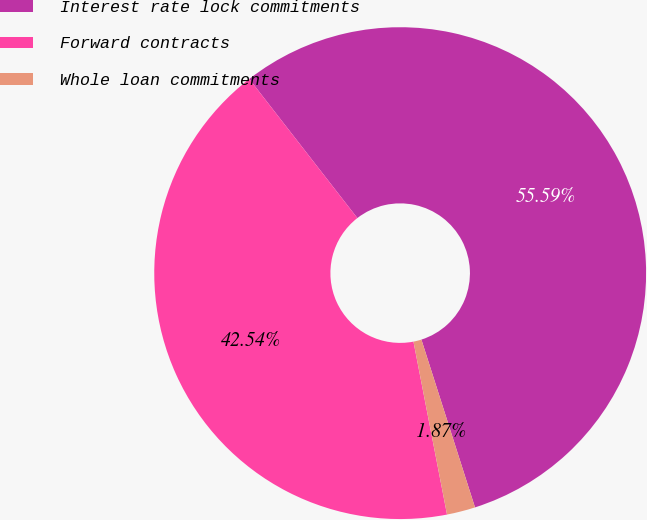Convert chart to OTSL. <chart><loc_0><loc_0><loc_500><loc_500><pie_chart><fcel>Interest rate lock commitments<fcel>Forward contracts<fcel>Whole loan commitments<nl><fcel>55.6%<fcel>42.54%<fcel>1.87%<nl></chart> 